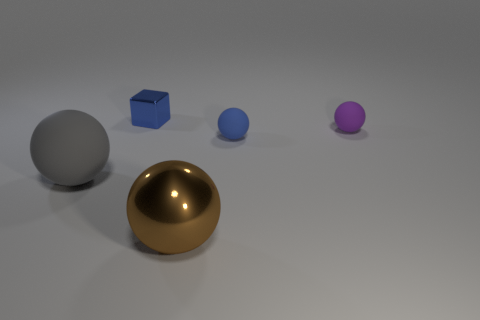Subtract all large brown balls. How many balls are left? 3 Subtract all purple spheres. How many spheres are left? 3 Add 3 tiny green objects. How many objects exist? 8 Subtract all balls. How many objects are left? 1 Subtract all brown spheres. Subtract all cyan cylinders. How many spheres are left? 3 Add 2 large blue matte cylinders. How many large blue matte cylinders exist? 2 Subtract 0 purple cylinders. How many objects are left? 5 Subtract all brown matte things. Subtract all tiny blue things. How many objects are left? 3 Add 2 small purple objects. How many small purple objects are left? 3 